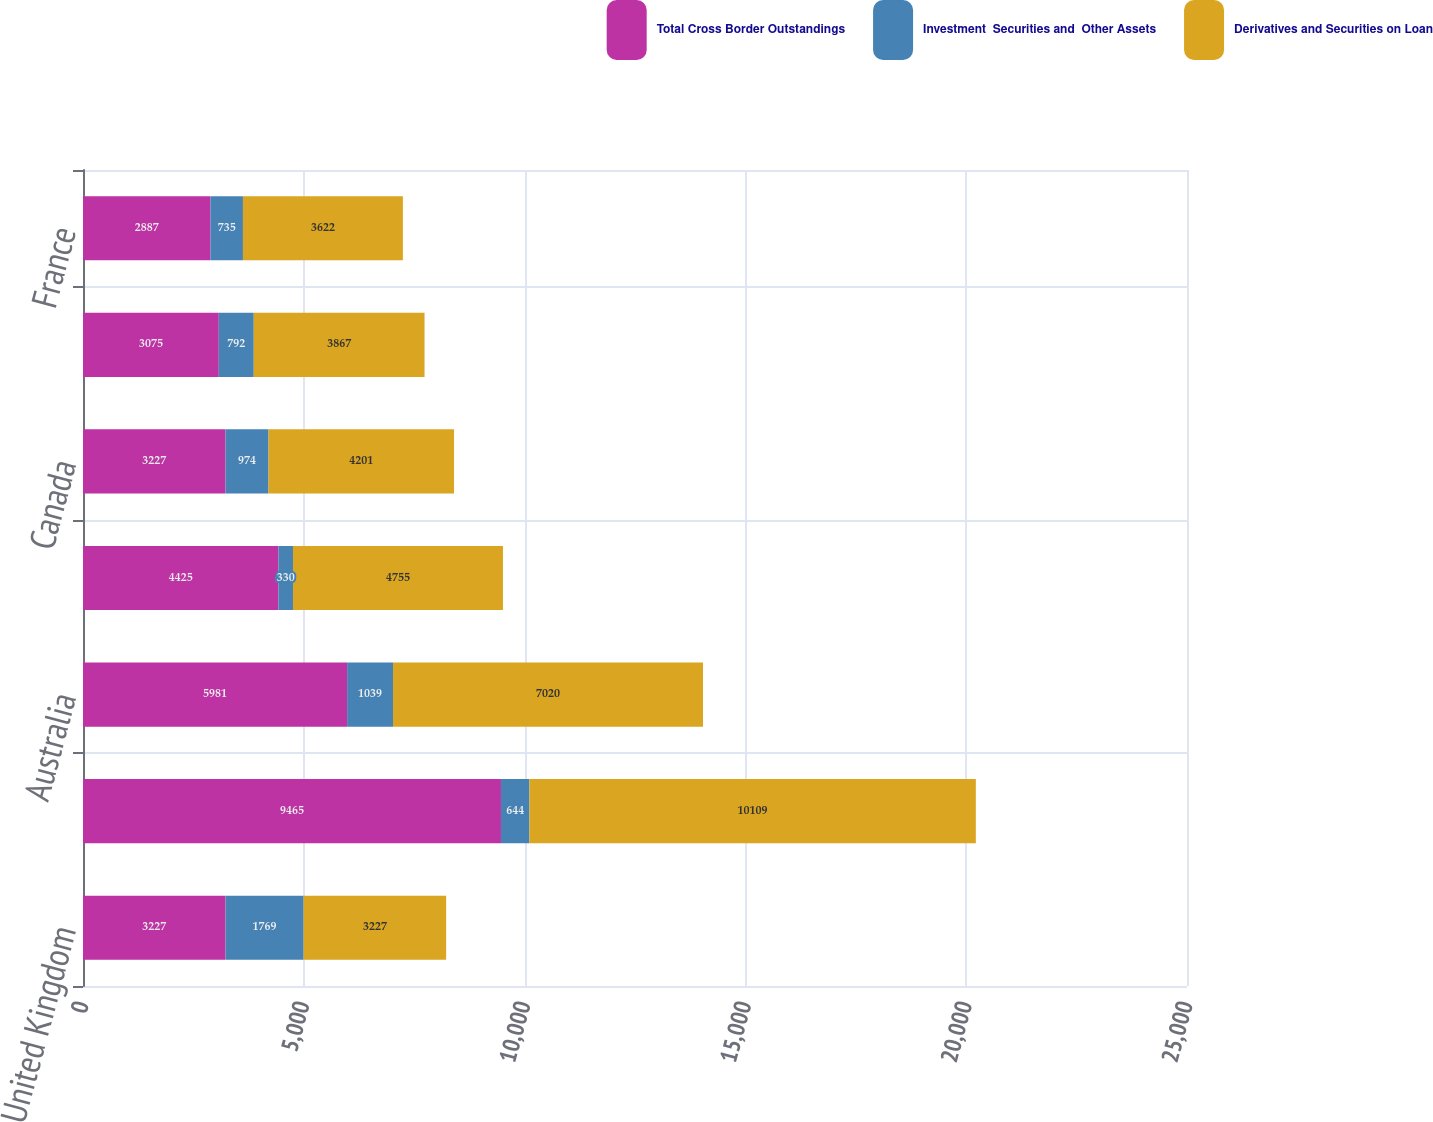<chart> <loc_0><loc_0><loc_500><loc_500><stacked_bar_chart><ecel><fcel>United Kingdom<fcel>Japan<fcel>Australia<fcel>Netherlands<fcel>Canada<fcel>Germany<fcel>France<nl><fcel>Total Cross Border Outstandings<fcel>3227<fcel>9465<fcel>5981<fcel>4425<fcel>3227<fcel>3075<fcel>2887<nl><fcel>Investment  Securities and  Other Assets<fcel>1769<fcel>644<fcel>1039<fcel>330<fcel>974<fcel>792<fcel>735<nl><fcel>Derivatives and Securities on Loan<fcel>3227<fcel>10109<fcel>7020<fcel>4755<fcel>4201<fcel>3867<fcel>3622<nl></chart> 